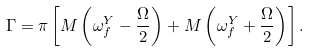<formula> <loc_0><loc_0><loc_500><loc_500>\Gamma = \pi \left [ M \left ( \omega ^ { Y } _ { f } - \frac { \Omega } { 2 } \right ) + M \left ( \omega ^ { Y } _ { f } + \frac { \Omega } { 2 } \right ) \right ] .</formula> 